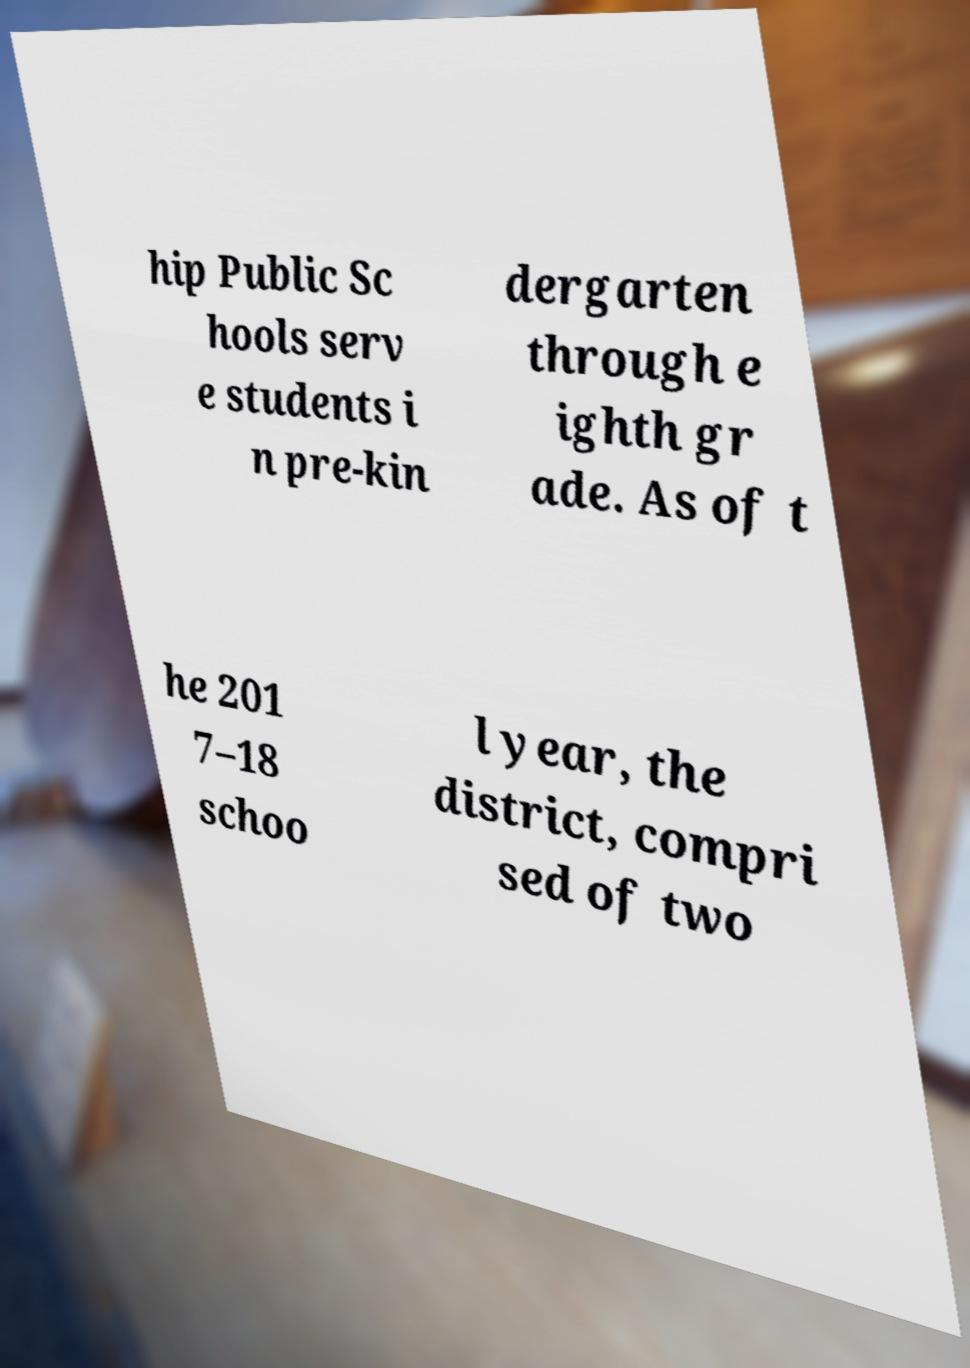Please read and relay the text visible in this image. What does it say? hip Public Sc hools serv e students i n pre-kin dergarten through e ighth gr ade. As of t he 201 7–18 schoo l year, the district, compri sed of two 